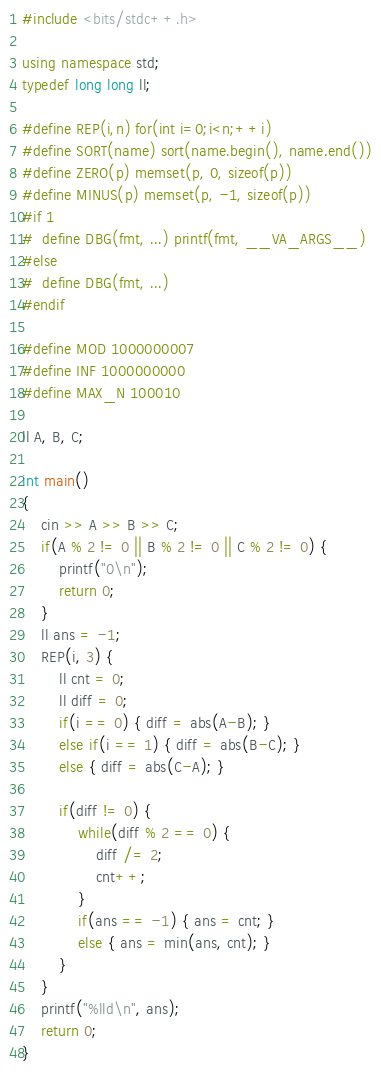Convert code to text. <code><loc_0><loc_0><loc_500><loc_500><_C++_>#include <bits/stdc++.h>

using namespace std;
typedef long long ll;

#define REP(i,n) for(int i=0;i<n;++i)
#define SORT(name) sort(name.begin(), name.end())
#define ZERO(p) memset(p, 0, sizeof(p))
#define MINUS(p) memset(p, -1, sizeof(p))
#if 1
#  define DBG(fmt, ...) printf(fmt, __VA_ARGS__)
#else
#  define DBG(fmt, ...)
#endif

#define MOD 1000000007
#define INF 1000000000
#define MAX_N 100010

ll A, B, C;

int main()
{
    cin >> A >> B >> C;
    if(A % 2 != 0 || B % 2 != 0 || C % 2 != 0) {
        printf("0\n");
        return 0;
    }
    ll ans = -1;
    REP(i, 3) {
        ll cnt = 0;
        ll diff = 0;
        if(i == 0) { diff = abs(A-B); }
        else if(i == 1) { diff = abs(B-C); }
        else { diff = abs(C-A); }

        if(diff != 0) {
            while(diff % 2 == 0) {
                diff /= 2;
                cnt++;
            }
            if(ans == -1) { ans = cnt; }
            else { ans = min(ans, cnt); }
        }
    }
    printf("%lld\n", ans);
    return 0;
}
</code> 